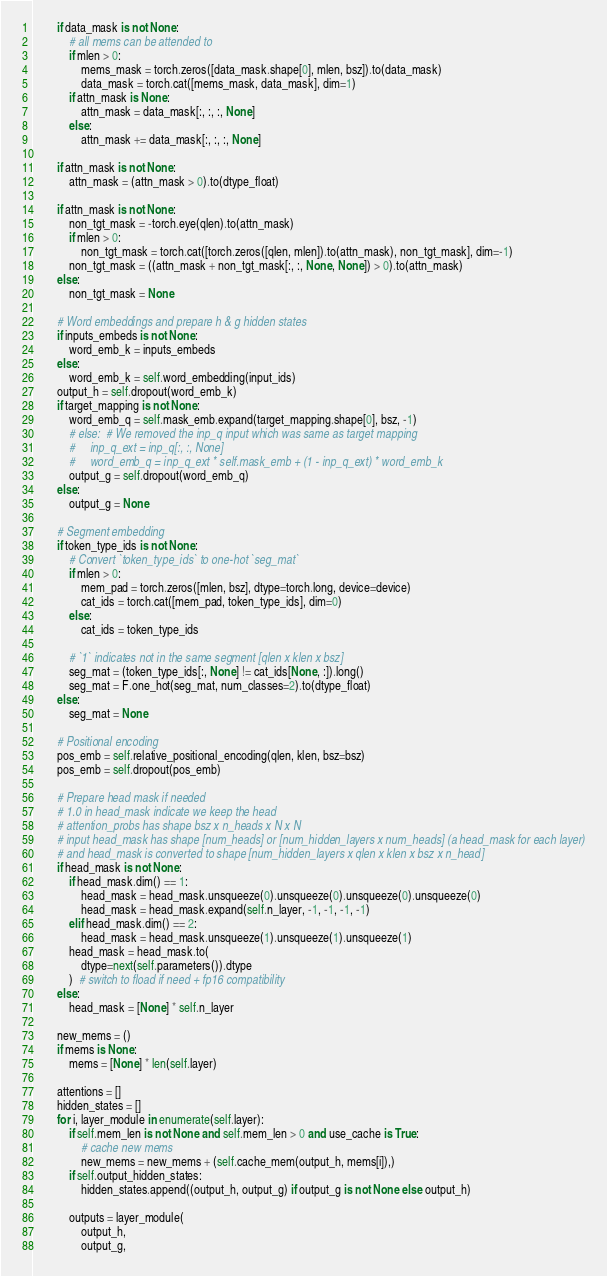<code> <loc_0><loc_0><loc_500><loc_500><_Python_>
        if data_mask is not None:
            # all mems can be attended to
            if mlen > 0:
                mems_mask = torch.zeros([data_mask.shape[0], mlen, bsz]).to(data_mask)
                data_mask = torch.cat([mems_mask, data_mask], dim=1)
            if attn_mask is None:
                attn_mask = data_mask[:, :, :, None]
            else:
                attn_mask += data_mask[:, :, :, None]

        if attn_mask is not None:
            attn_mask = (attn_mask > 0).to(dtype_float)

        if attn_mask is not None:
            non_tgt_mask = -torch.eye(qlen).to(attn_mask)
            if mlen > 0:
                non_tgt_mask = torch.cat([torch.zeros([qlen, mlen]).to(attn_mask), non_tgt_mask], dim=-1)
            non_tgt_mask = ((attn_mask + non_tgt_mask[:, :, None, None]) > 0).to(attn_mask)
        else:
            non_tgt_mask = None

        # Word embeddings and prepare h & g hidden states
        if inputs_embeds is not None:
            word_emb_k = inputs_embeds
        else:
            word_emb_k = self.word_embedding(input_ids)
        output_h = self.dropout(word_emb_k)
        if target_mapping is not None:
            word_emb_q = self.mask_emb.expand(target_mapping.shape[0], bsz, -1)
            # else:  # We removed the inp_q input which was same as target mapping
            #     inp_q_ext = inp_q[:, :, None]
            #     word_emb_q = inp_q_ext * self.mask_emb + (1 - inp_q_ext) * word_emb_k
            output_g = self.dropout(word_emb_q)
        else:
            output_g = None

        # Segment embedding
        if token_type_ids is not None:
            # Convert `token_type_ids` to one-hot `seg_mat`
            if mlen > 0:
                mem_pad = torch.zeros([mlen, bsz], dtype=torch.long, device=device)
                cat_ids = torch.cat([mem_pad, token_type_ids], dim=0)
            else:
                cat_ids = token_type_ids

            # `1` indicates not in the same segment [qlen x klen x bsz]
            seg_mat = (token_type_ids[:, None] != cat_ids[None, :]).long()
            seg_mat = F.one_hot(seg_mat, num_classes=2).to(dtype_float)
        else:
            seg_mat = None

        # Positional encoding
        pos_emb = self.relative_positional_encoding(qlen, klen, bsz=bsz)
        pos_emb = self.dropout(pos_emb)

        # Prepare head mask if needed
        # 1.0 in head_mask indicate we keep the head
        # attention_probs has shape bsz x n_heads x N x N
        # input head_mask has shape [num_heads] or [num_hidden_layers x num_heads] (a head_mask for each layer)
        # and head_mask is converted to shape [num_hidden_layers x qlen x klen x bsz x n_head]
        if head_mask is not None:
            if head_mask.dim() == 1:
                head_mask = head_mask.unsqueeze(0).unsqueeze(0).unsqueeze(0).unsqueeze(0)
                head_mask = head_mask.expand(self.n_layer, -1, -1, -1, -1)
            elif head_mask.dim() == 2:
                head_mask = head_mask.unsqueeze(1).unsqueeze(1).unsqueeze(1)
            head_mask = head_mask.to(
                dtype=next(self.parameters()).dtype
            )  # switch to fload if need + fp16 compatibility
        else:
            head_mask = [None] * self.n_layer

        new_mems = ()
        if mems is None:
            mems = [None] * len(self.layer)

        attentions = []
        hidden_states = []
        for i, layer_module in enumerate(self.layer):
            if self.mem_len is not None and self.mem_len > 0 and use_cache is True:
                # cache new mems
                new_mems = new_mems + (self.cache_mem(output_h, mems[i]),)
            if self.output_hidden_states:
                hidden_states.append((output_h, output_g) if output_g is not None else output_h)

            outputs = layer_module(
                output_h,
                output_g,</code> 